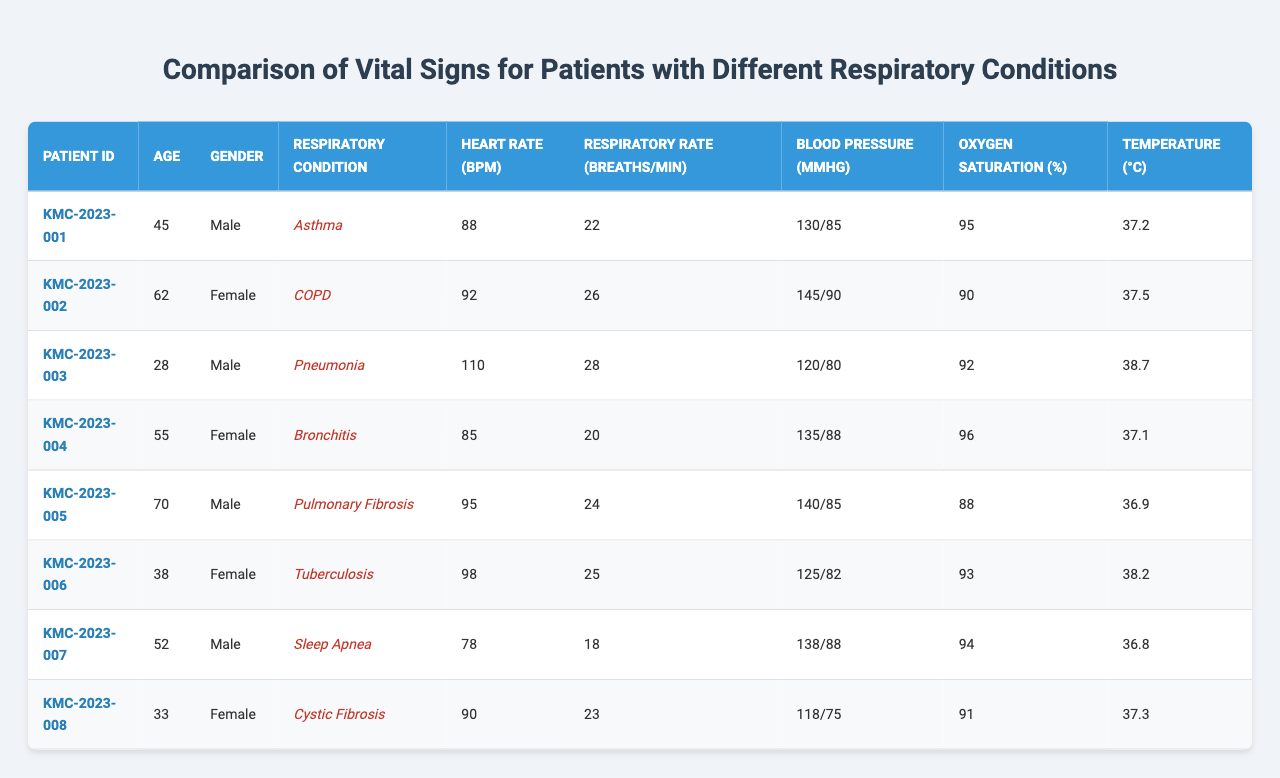What is the heart rate of the patient with pneumonia? The heart rate of the patient diagnosed with pneumonia (Patient ID KMC-2023-003) is listed in the table as 110 bpm.
Answer: 110 bpm Which respiratory condition has the highest average respiratory rate? To find the average respiratory rate for each condition: Asthma: 22, COPD: 26, Pneumonia: 28, Bronchitis: 20, Pulmonary Fibrosis: 24, Tuberculosis: 25, Sleep Apnea: 18, Cystic Fibrosis: 23. The highest average is for Pneumonia (28 breaths/min).
Answer: Pneumonia Is the oxygen saturation for the patient with COPD below 95%? The oxygen saturation for the patient with COPD (Patient ID KMC-2023-002) is listed as 90%, which is indeed below 95%.
Answer: Yes What is the age of the youngest patient, and what condition do they have? The ages are: Asthma: 45, COPD: 62, Pneumonia: 28, Bronchitis: 55, Pulmonary Fibrosis: 70, Tuberculosis: 38, Sleep Apnea: 52, Cystic Fibrosis: 33. The youngest is 28 years old with a condition of Pneumonia.
Answer: 28 years, Pneumonia What is the difference in heart rate between the patient with Tuberculosis and the one with Sleep Apnea? The heart rate for Tuberculosis (Patient ID KMC-2023-006) is 98 bpm, while for Sleep Apnea (Patient ID KMC-2023-007) it is 78 bpm. The difference is 98 - 78 = 20 bpm.
Answer: 20 bpm Among all patients, which one has the lowest blood pressure and what is that value? Checking the blood pressure values: Asthma: 130/85, COPD: 145/90, Pneumonia: 120/80, Bronchitis: 135/88, Pulmonary Fibrosis: 140/85, Tuberculosis: 125/82, Sleep Apnea: 138/88, Cystic Fibrosis: 118/75. The lowest is 118/75 (Cystic Fibrosis).
Answer: 118/75 Which gender has the highest average temperature of patients? The temperatures for males are: 37.2 (Asthma), 38.7 (Pneumonia), 36.9 (Pulmonary Fibrosis), 36.8 (Sleep Apnea) - average = (37.2 + 38.7 + 36.9 + 36.8) / 4 = 37.4°C. For females: 37.5 (COPD), 37.1 (Bronchitis), 38.2 (Tuberculosis), 37.3 (Cystic Fibrosis) - average = (37.5 + 37.1 + 38.2 + 37.3) / 4 = 37.5°C. The highest average temperature is for females.
Answer: Females What is the most common respiratory condition in this dataset? The list of conditions is: Asthma, COPD, Pneumonia, Bronchitis, Pulmonary Fibrosis, Tuberculosis, Sleep Apnea, Cystic Fibrosis (each represented once). There is no most common condition as all have one patient each.
Answer: None What is the average blood pressure across all patients? The blood pressures are: 130/85, 145/90, 120/80, 135/88, 140/85, 125/82, 138/88, 118/75. To calculate average, convert to systolic and diastolic separately: Avg systolic = (130 + 145 + 120 + 135 + 140 + 125 + 138 + 118) / 8 = 130.625; Avg diastolic = (85 + 90 + 80 + 88 + 85 + 82 + 88 + 75) / 8 = 83.125. The average BP is approximately 130/83 mmHg.
Answer: 130/83 mmHg How many patients have an oxygen saturation level of 90% or below? The patients with saturation of 90% or below are: COPD (90%), Pulmonary Fibrosis (88%). Thus, there are 2 patients with saturation levels of 90% or below.
Answer: 2 patients 